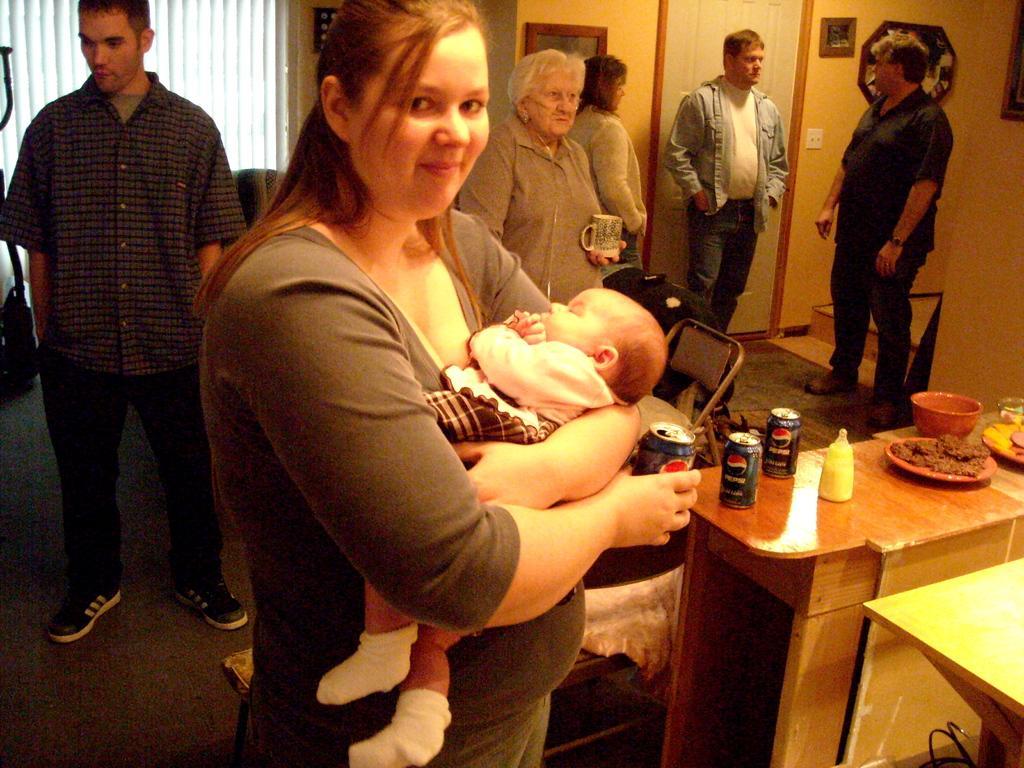Could you give a brief overview of what you see in this image? This image is clicked inside a room. There are seven persons in this image, six adults and one infant. In the front, the woman is holding a kid in her hands, and a tin. To the left there is a man standing, wearing black and gray shirt. To the right, there is table, on which there are coke tins, milk bottle, and bowl, plates. In the background, there is a wall, door , and photo frame on the wall. 